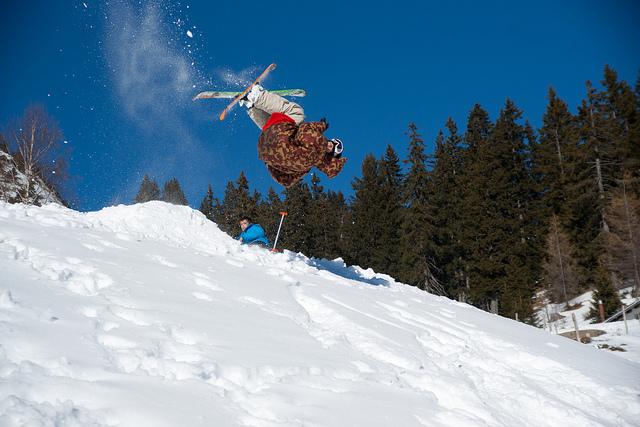What trick is the snowboarder doing?
Give a very brief answer. Flip. Why are there footprints?
Keep it brief. People walking. What is this guy participating in?
Short answer required. Skiing. What color is the jacket of the person on top of the hill?
Concise answer only. Blue. 